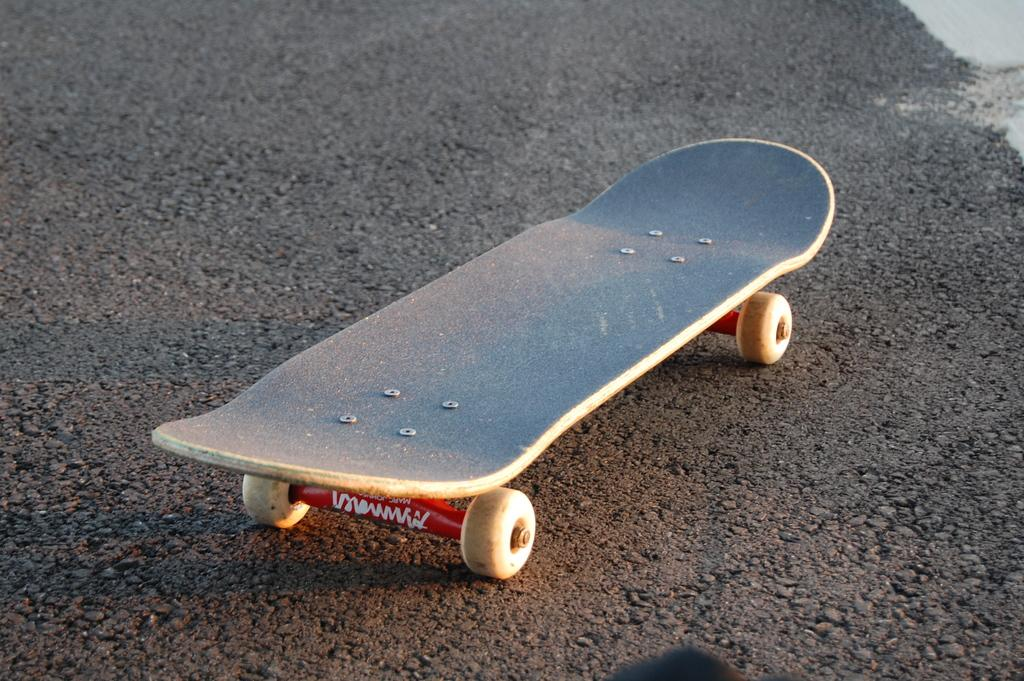What object is present on the road in the image? There is a skateboard on the road in the image. What type of wool is used to make the memory foam in the image? There is no memory foam or wool present in the image; it features a skateboard on the road. 